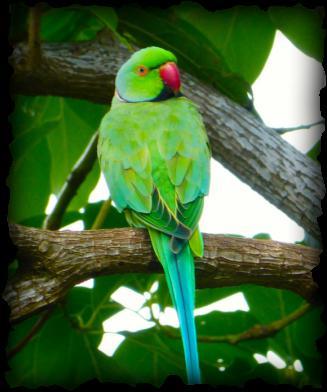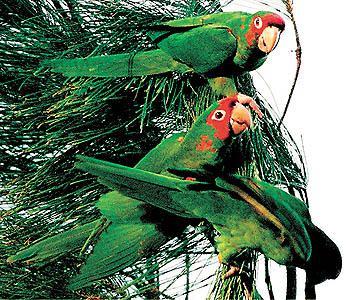The first image is the image on the left, the second image is the image on the right. Given the left and right images, does the statement "There is at least one image where there is a cage." hold true? Answer yes or no. No. The first image is the image on the left, the second image is the image on the right. Analyze the images presented: Is the assertion "In one image there are 3 parrots standing on a branch" valid? Answer yes or no. No. 